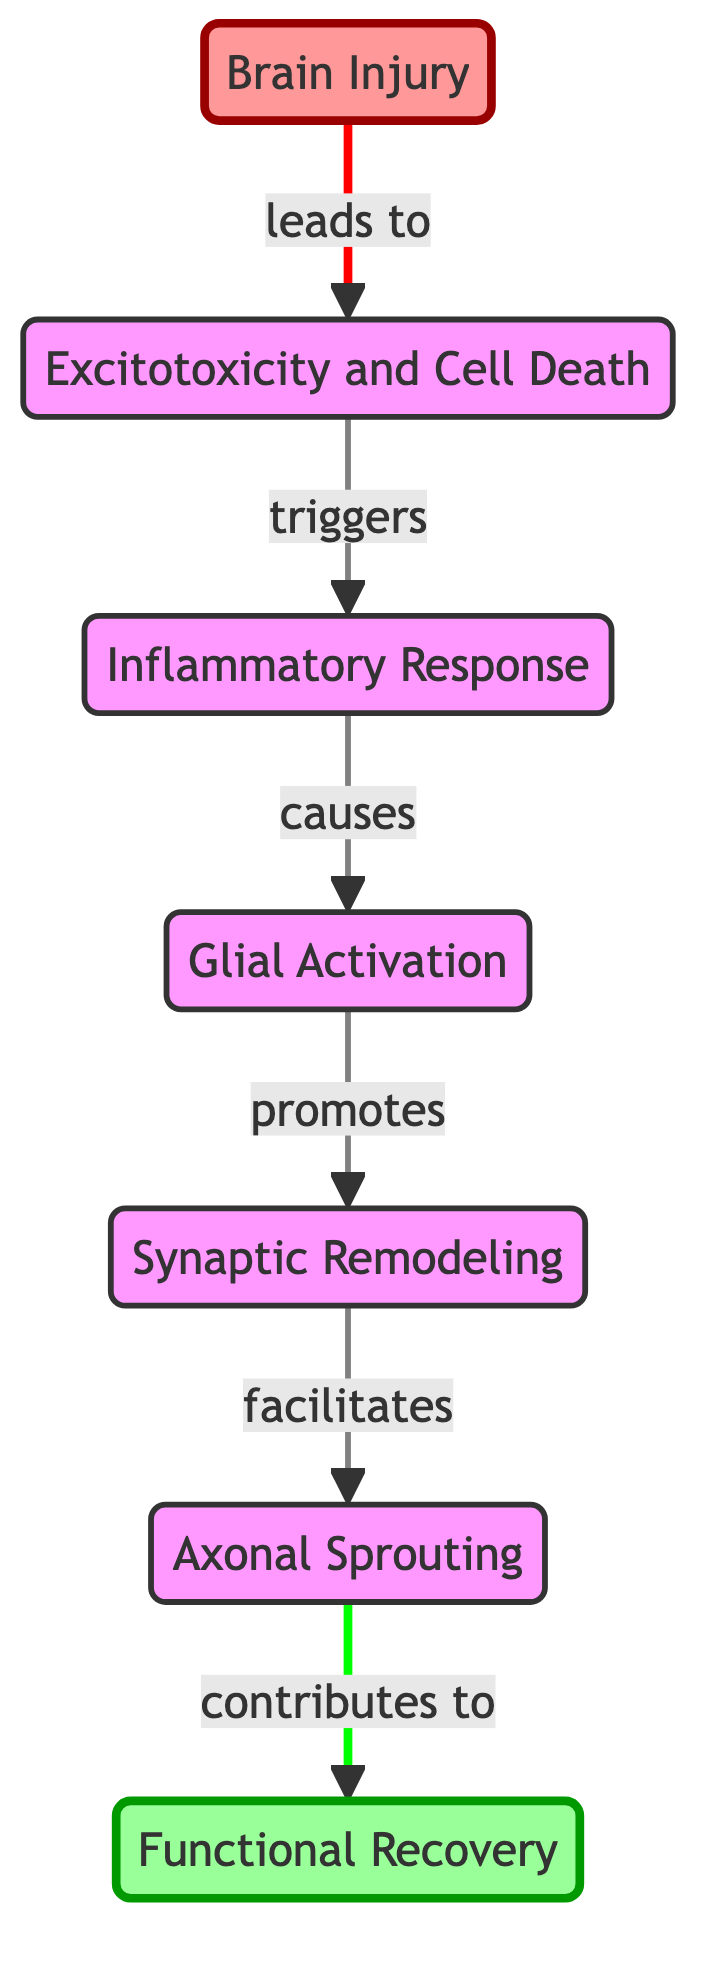What is the first stage following a brain injury? The diagram outlines the sequence of stages following a brain injury, indicating that the first stage is represented by the node labeled "Brain Injury."
Answer: Brain Injury How many total nodes are present in the diagram? By counting the distinct nodes listed in the diagram, we find that there are a total of seven nodes representing different stages or components.
Answer: 7 What does excitotoxicity lead to? The directed edge from the node "Excitotoxicity and Cell Death" points to the node "Inflammatory Response," indicating that excitotoxicity leads to inflammation.
Answer: Inflammatory Response Which process promotes synaptic remodeling? The edge labeled "promotes" connects the "Glial Activation" node to the "Synaptic Remodeling" node, signifying that glial activation promotes synaptic remodeling.
Answer: Glial Activation What contributes to functional recovery? According to the diagram, the node "Axonal Sprouting" leads to functional recovery, highlighting its contribution to the recovery process.
Answer: Axonal Sprouting Which node has the most incoming edges? The node with the most incoming edges must be "Glial Activation," as it is connected by the edges from "Inflammatory Response." This indicates that glial activation receives input from the inflammatory response.
Answer: Glial Activation What is the relationship between inflammation and glial activation? The diagram indicates that inflammation causes glial activation, as denoted by the edge connecting these two nodes with the label "causes."
Answer: causes What comes after synaptic remodeling in the sequence? The directed flow in the diagram shows that after synaptic remodeling, the next step is axonal sprouting, as indicated by the edge labeled "facilitates."
Answer: Axonal Sprouting 